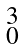Convert formula to latex. <formula><loc_0><loc_0><loc_500><loc_500>\begin{smallmatrix} 3 \\ 0 \\ \end{smallmatrix}</formula> 